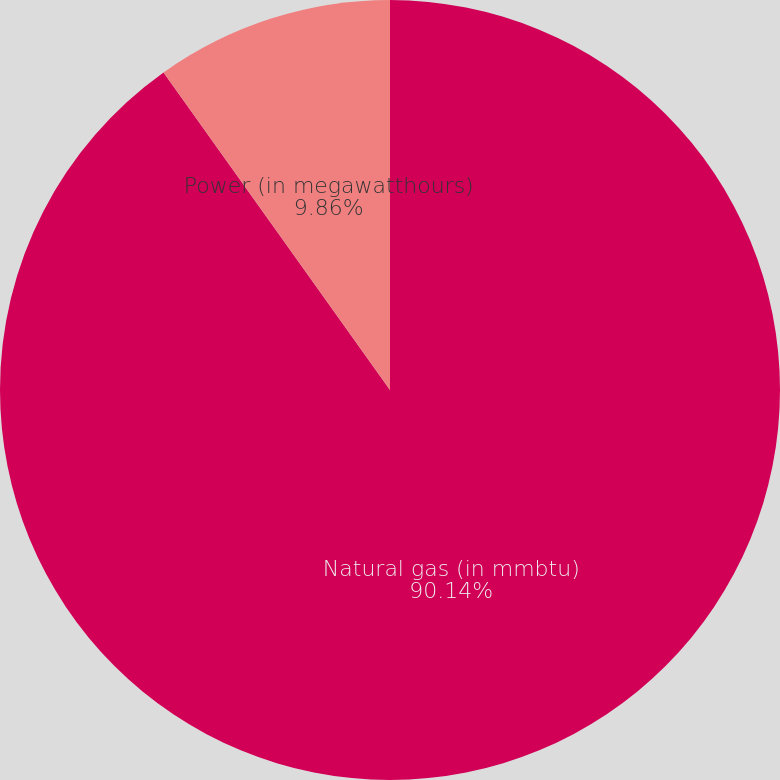Convert chart to OTSL. <chart><loc_0><loc_0><loc_500><loc_500><pie_chart><fcel>Natural gas (in mmbtu)<fcel>Power (in megawatthours)<nl><fcel>90.14%<fcel>9.86%<nl></chart> 